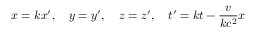Convert formula to latex. <formula><loc_0><loc_0><loc_500><loc_500>x = k x ^ { \prime } , \quad y = y ^ { \prime } , \quad z = z ^ { \prime } , \quad t ^ { \prime } = k t - { \frac { v } { k c ^ { 2 } } } x</formula> 